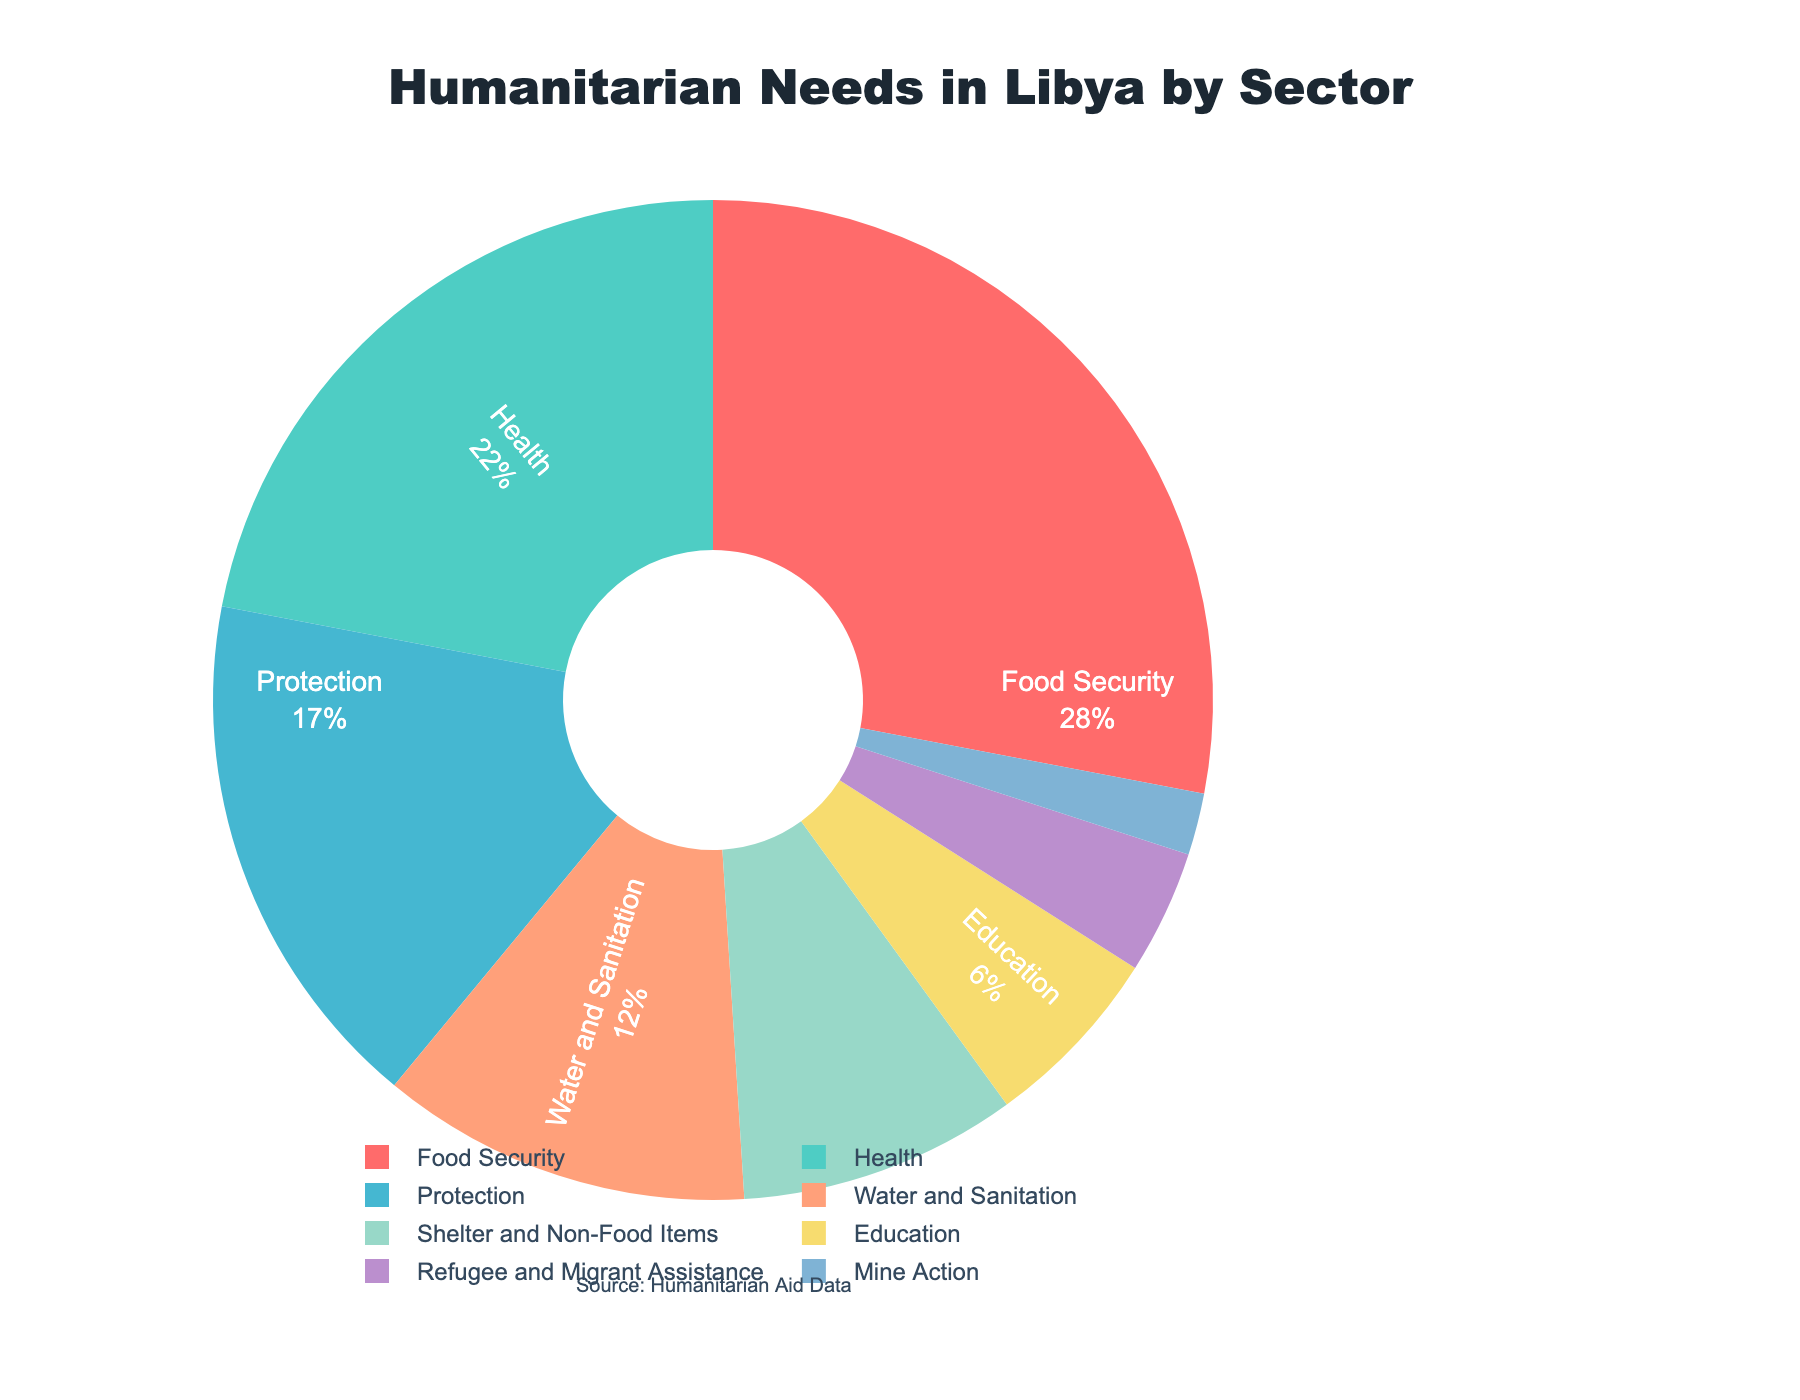What sector has the highest percentage of humanitarian needs in Libya? The sector with the highest percentage of humanitarian needs in Libya is Food Security, which is 28%.
Answer: Food Security Which sector requires more humanitarian assistance, Health or Education? Comparing the percentages, Health requires 22% and Education requires 6%. Since 22% is greater than 6%, Health requires more humanitarian assistance than Education.
Answer: Health How much higher is the percentage of Water and Sanitation needs compared to Shelter and Non-Food Items? The percentage of Water and Sanitation is 12%, and Shelter and Non-Food Items is 9%. The difference is 12% - 9% = 3%.
Answer: 3% What is the combined percentage for Protection and Mine Action needs? The percentage for Protection is 17%, and for Mine Action is 2%. The combined percentage is 17% + 2% = 19%.
Answer: 19% What is the total percentage for sectors that have a percentage greater than 10%? The sectors with percentages greater than 10% are Food Security (28%), Health (22%), Protection (17%), and Water and Sanitation (12%). The total percentage is 28% + 22% + 17% + 12% = 79%.
Answer: 79% Which sector has the smallest percentage of humanitarian needs? The sector with the smallest percentage of humanitarian needs is Mine Action with 2%.
Answer: Mine Action By how much does the percentage of Food Security exceed that of Health? The percentage for Food Security is 28%, and for Health is 22%. The difference is 28% - 22% = 6%.
Answer: 6% What sectors have their humanitarian needs accounted for less than 10%? The sectors with less than 10% are Shelter and Non-Food Items (9%), Education (6%), Refugee and Migrant Assistance (4%), and Mine Action (2%).
Answer: Shelter and Non-Food Items, Education, Refugee and Migrant Assistance, Mine Action If 10 sectors were represented in the chart, how much would each need to contribute on average to make up the 100%? To find the average each sector needs to contribute, divide 100% by 10 sectors: 100% / 10 = 10%.
Answer: 10% 